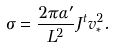<formula> <loc_0><loc_0><loc_500><loc_500>\sigma = \frac { 2 \pi \alpha ^ { \prime } } { L ^ { 2 } } J ^ { t } v ^ { 2 } _ { \ast } .</formula> 